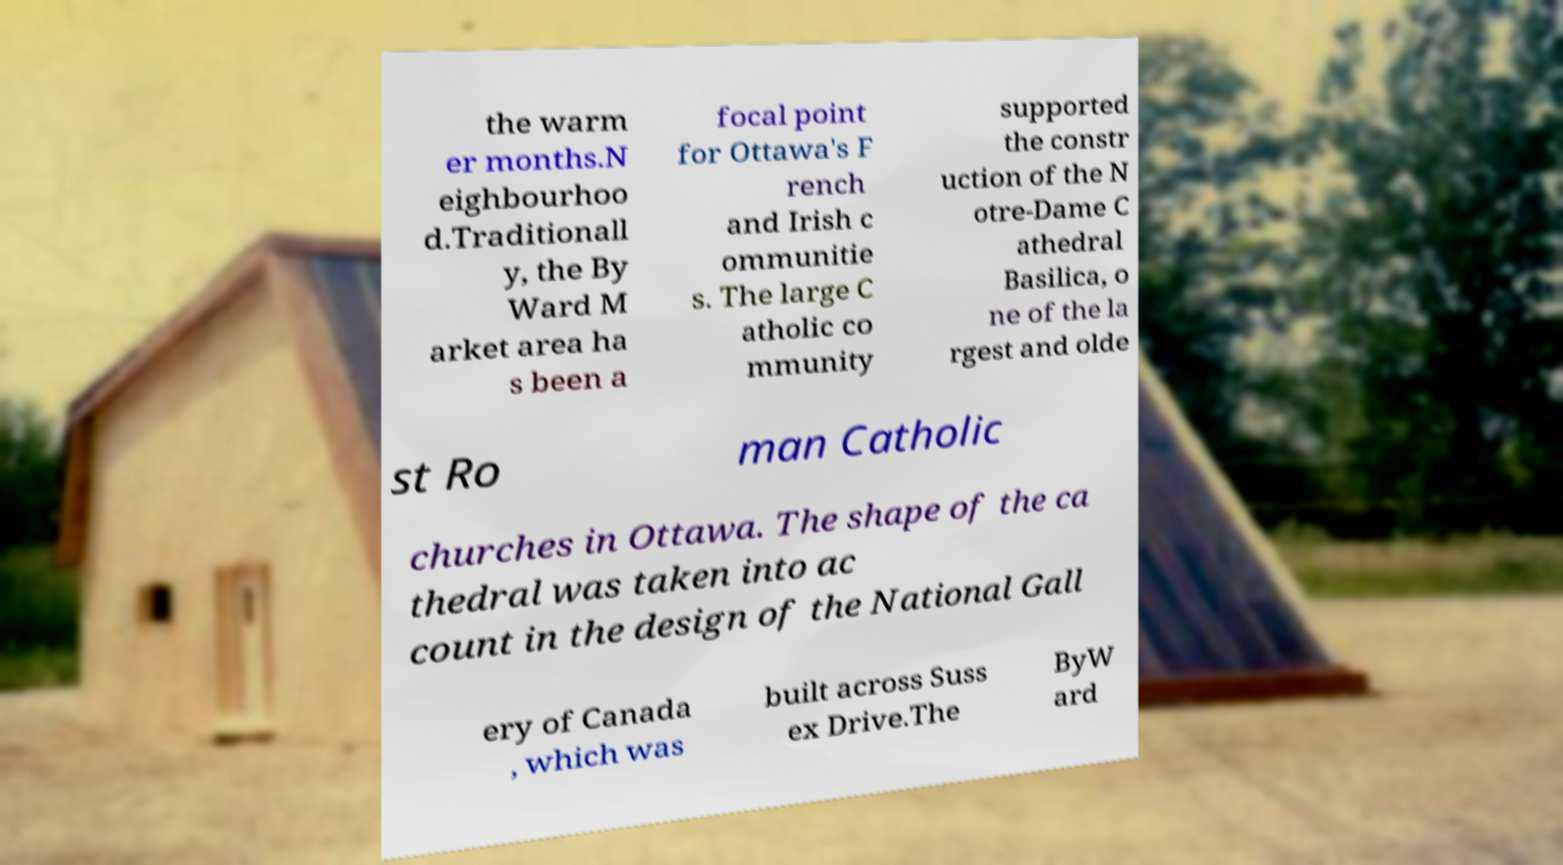For documentation purposes, I need the text within this image transcribed. Could you provide that? the warm er months.N eighbourhoo d.Traditionall y, the By Ward M arket area ha s been a focal point for Ottawa's F rench and Irish c ommunitie s. The large C atholic co mmunity supported the constr uction of the N otre-Dame C athedral Basilica, o ne of the la rgest and olde st Ro man Catholic churches in Ottawa. The shape of the ca thedral was taken into ac count in the design of the National Gall ery of Canada , which was built across Suss ex Drive.The ByW ard 